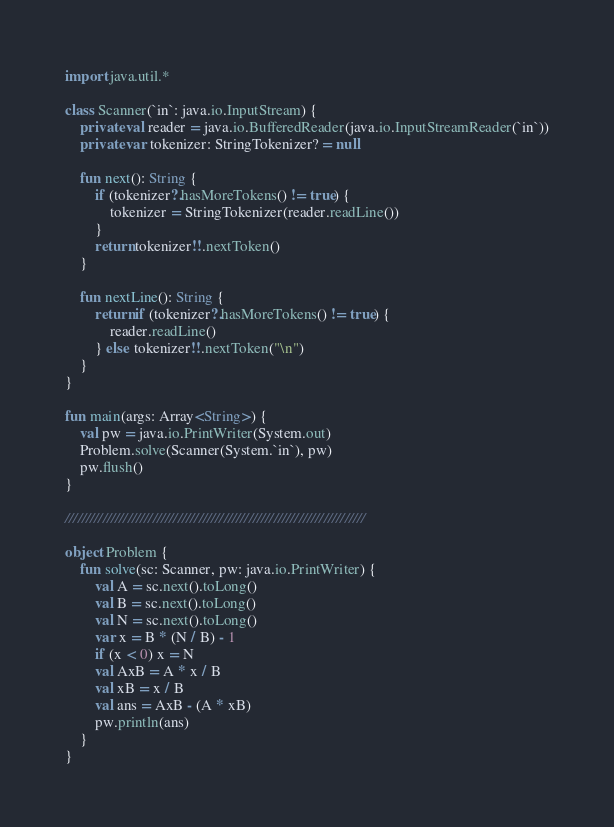<code> <loc_0><loc_0><loc_500><loc_500><_Kotlin_>import java.util.*

class Scanner(`in`: java.io.InputStream) {
    private val reader = java.io.BufferedReader(java.io.InputStreamReader(`in`))
    private var tokenizer: StringTokenizer? = null

    fun next(): String {
        if (tokenizer?.hasMoreTokens() != true) {
            tokenizer = StringTokenizer(reader.readLine())
        }
        return tokenizer!!.nextToken()
    }

    fun nextLine(): String {
        return if (tokenizer?.hasMoreTokens() != true) {
            reader.readLine()
        } else tokenizer!!.nextToken("\n")
    }
}

fun main(args: Array<String>) {
    val pw = java.io.PrintWriter(System.out)
    Problem.solve(Scanner(System.`in`), pw)
    pw.flush()
}

////////////////////////////////////////////////////////////////////////

object Problem {
    fun solve(sc: Scanner, pw: java.io.PrintWriter) {
        val A = sc.next().toLong()
        val B = sc.next().toLong()
        val N = sc.next().toLong()
        var x = B * (N / B) - 1
        if (x < 0) x = N
        val AxB = A * x / B
        val xB = x / B
        val ans = AxB - (A * xB)
        pw.println(ans)
    }
}
</code> 